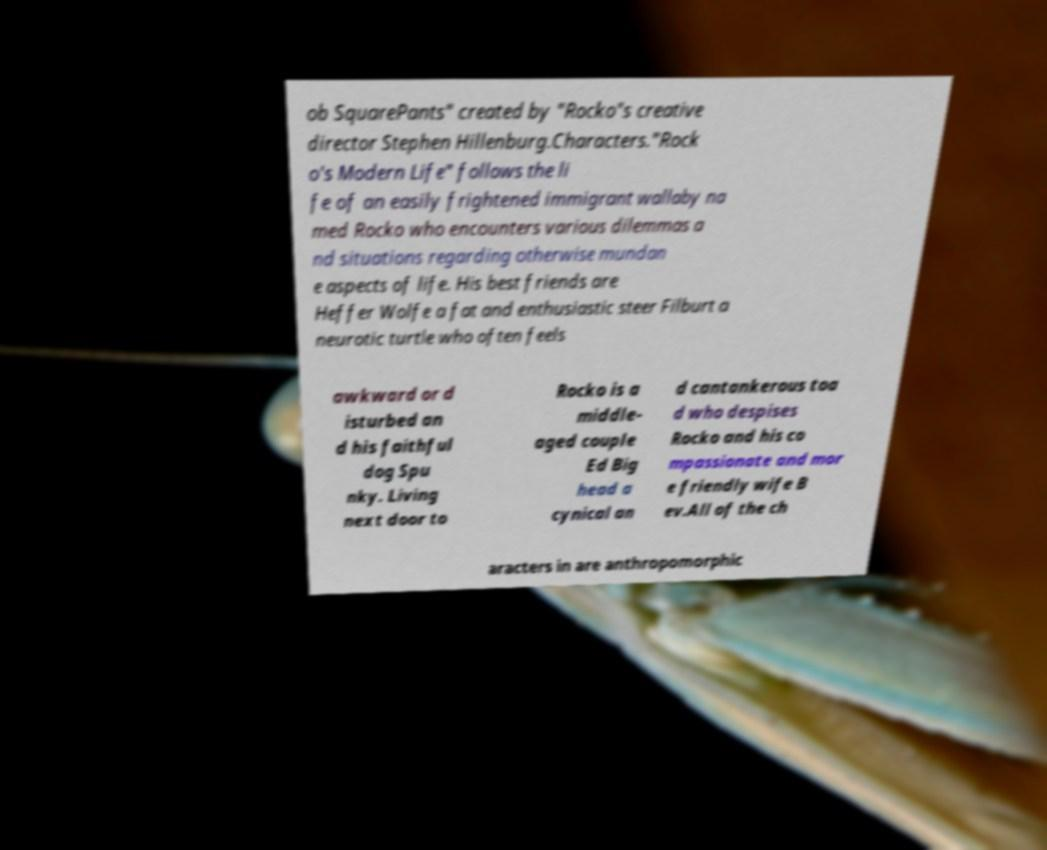Please read and relay the text visible in this image. What does it say? ob SquarePants" created by "Rocko"s creative director Stephen Hillenburg.Characters."Rock o's Modern Life" follows the li fe of an easily frightened immigrant wallaby na med Rocko who encounters various dilemmas a nd situations regarding otherwise mundan e aspects of life. His best friends are Heffer Wolfe a fat and enthusiastic steer Filburt a neurotic turtle who often feels awkward or d isturbed an d his faithful dog Spu nky. Living next door to Rocko is a middle- aged couple Ed Big head a cynical an d cantankerous toa d who despises Rocko and his co mpassionate and mor e friendly wife B ev.All of the ch aracters in are anthropomorphic 